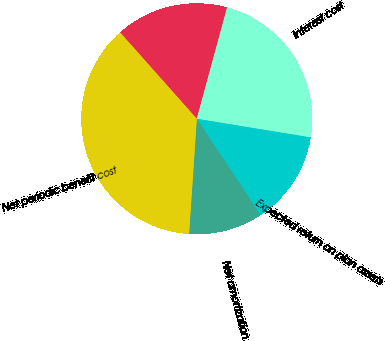Convert chart to OTSL. <chart><loc_0><loc_0><loc_500><loc_500><pie_chart><fcel>Service cost<fcel>Interest cost<fcel>Expected return on plan assets<fcel>Net amortization<fcel>Net periodic benefit cost<nl><fcel>15.79%<fcel>23.35%<fcel>13.09%<fcel>10.39%<fcel>37.37%<nl></chart> 